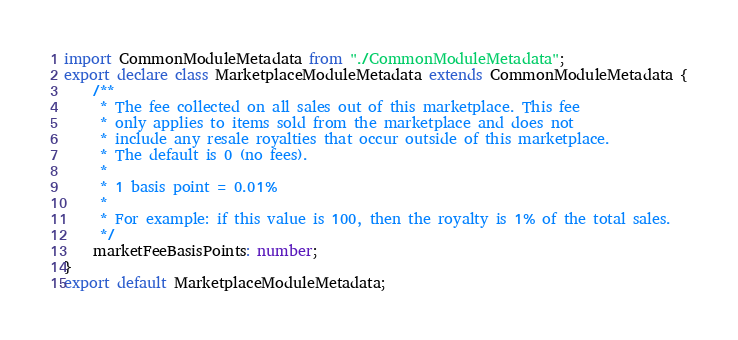<code> <loc_0><loc_0><loc_500><loc_500><_TypeScript_>import CommonModuleMetadata from "./CommonModuleMetadata";
export declare class MarketplaceModuleMetadata extends CommonModuleMetadata {
    /**
     * The fee collected on all sales out of this marketplace. This fee
     * only applies to items sold from the marketplace and does not
     * include any resale royalties that occur outside of this marketplace.
     * The default is 0 (no fees).
     *
     * 1 basis point = 0.01%
     *
     * For example: if this value is 100, then the royalty is 1% of the total sales.
     */
    marketFeeBasisPoints: number;
}
export default MarketplaceModuleMetadata;
</code> 